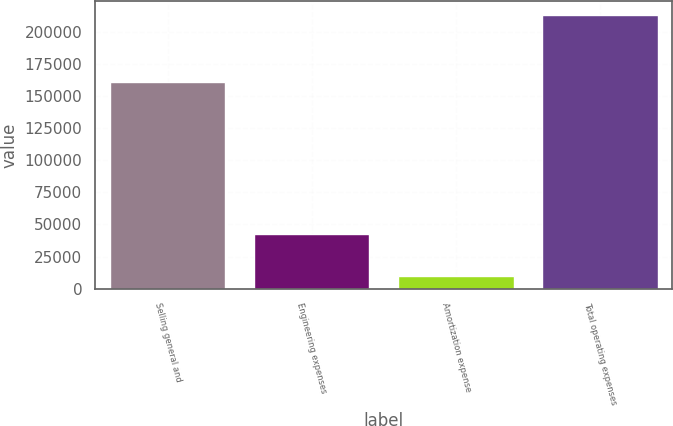<chart> <loc_0><loc_0><loc_500><loc_500><bar_chart><fcel>Selling general and<fcel>Engineering expenses<fcel>Amortization expense<fcel>Total operating expenses<nl><fcel>160998<fcel>42447<fcel>9849<fcel>213294<nl></chart> 